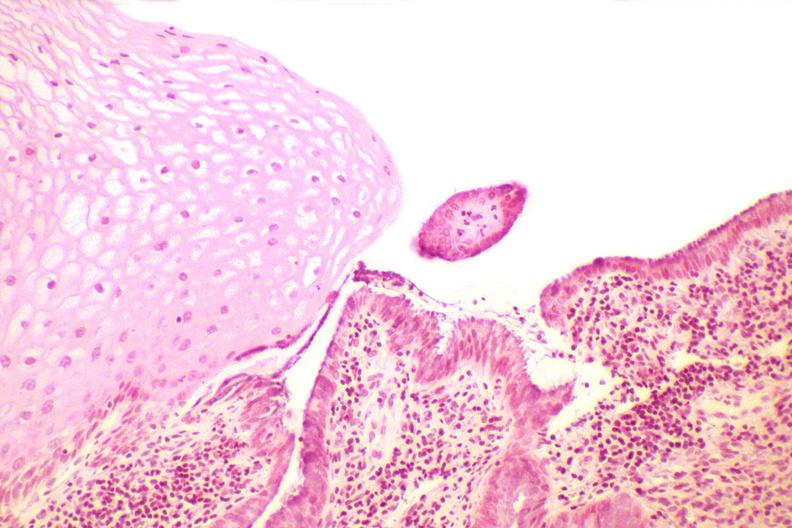does this image show cervix, squamocolumnar junction?
Answer the question using a single word or phrase. Yes 